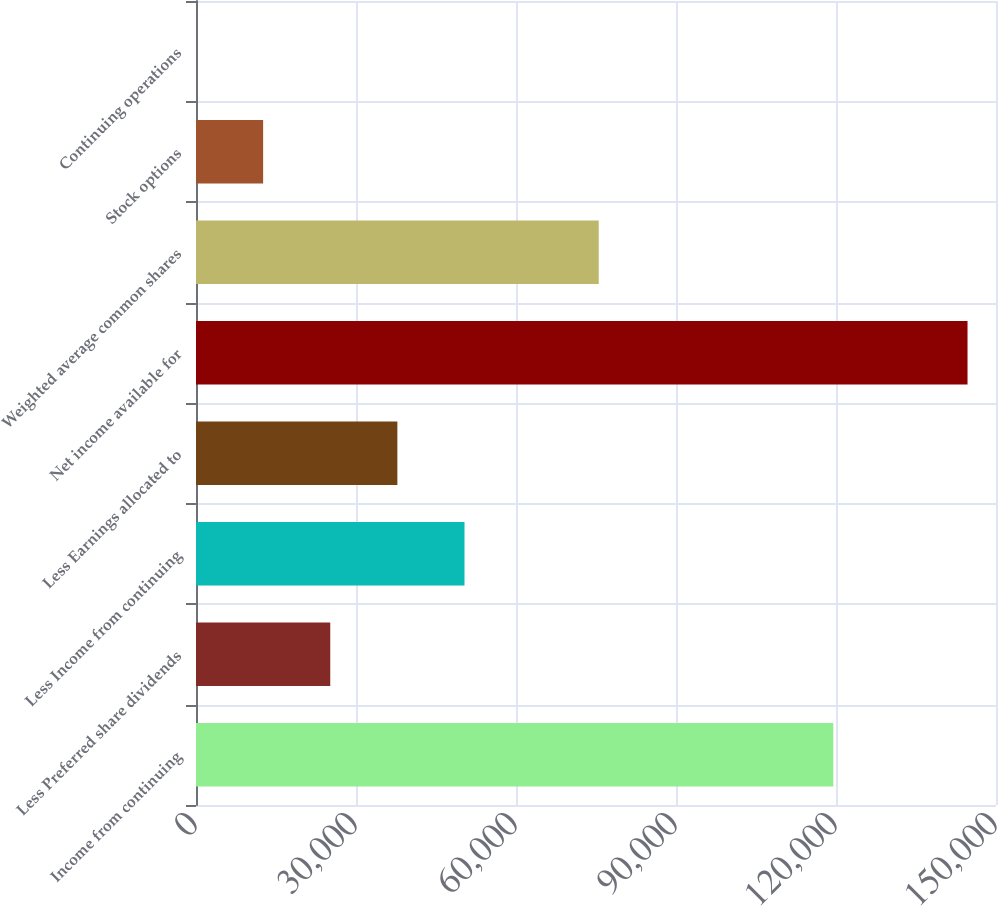<chart> <loc_0><loc_0><loc_500><loc_500><bar_chart><fcel>Income from continuing<fcel>Less Preferred share dividends<fcel>Less Income from continuing<fcel>Less Earnings allocated to<fcel>Net income available for<fcel>Weighted average common shares<fcel>Stock options<fcel>Continuing operations<nl><fcel>119491<fcel>25171.8<fcel>50341.6<fcel>37756.7<fcel>144661<fcel>75511.4<fcel>12586.9<fcel>1.95<nl></chart> 